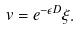Convert formula to latex. <formula><loc_0><loc_0><loc_500><loc_500>v = e ^ { - \epsilon D } \xi .</formula> 